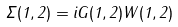<formula> <loc_0><loc_0><loc_500><loc_500>\Sigma ( 1 , 2 ) = i G ( 1 , 2 ) W ( 1 , 2 )</formula> 